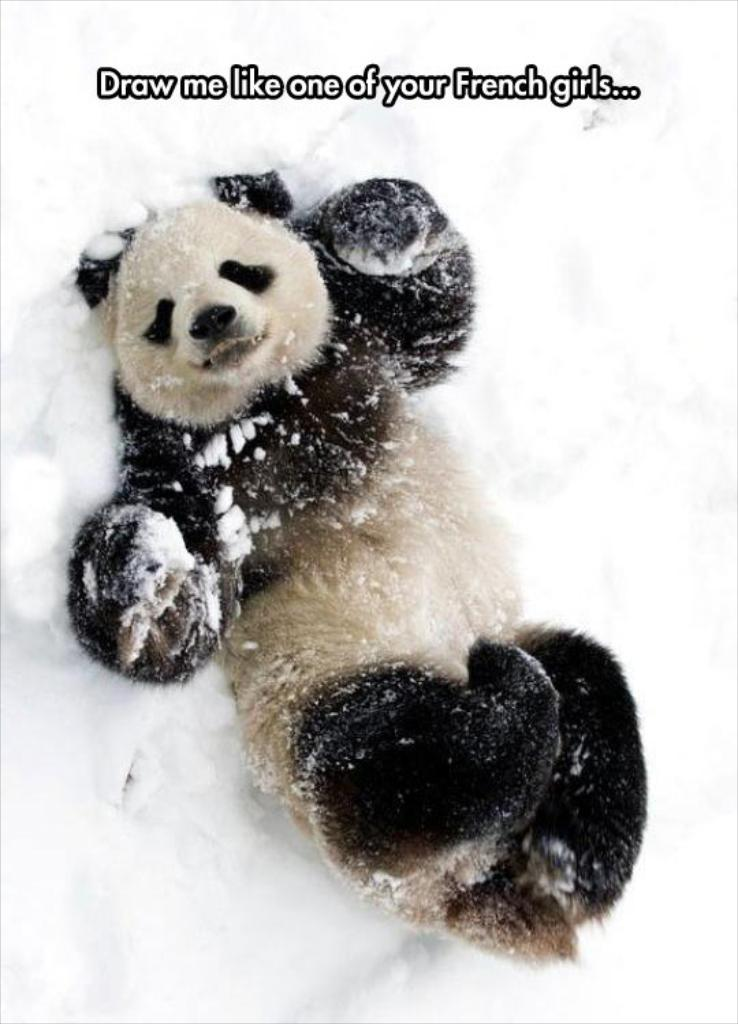What is the main subject of the image? There is a panda in the center of the image. What is the panda standing on? The panda is on the snow. What is the name of the person who gave birth to the panda in the image? There is no person present in the image, and pandas are born from their mothers, not from human beings. 